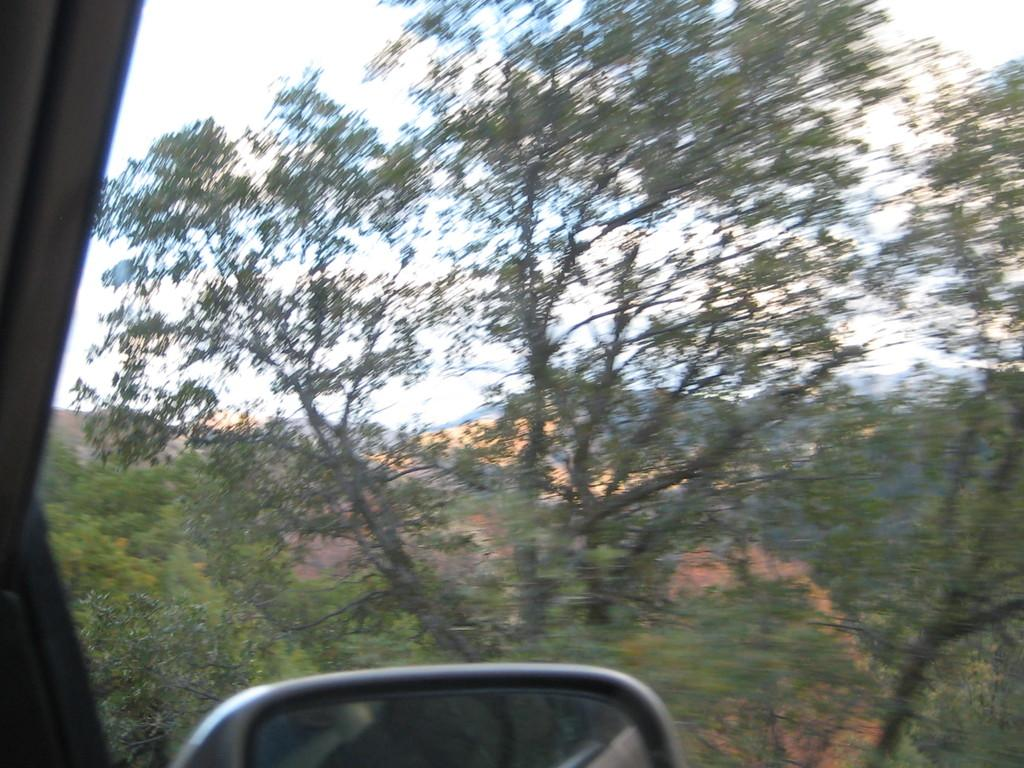What type of transparent material is present in the image? There is a glass window in the image. What is another reflective surface that can be seen in the image? There is a mirror in the image. What can be seen through the glass window? Trees and mountains are visible through the glass window. What is visible at the top of the image? The sky is visible at the top of the image. How many marks are visible on the mirror in the image? There are no marks visible on the mirror in the image. What is the fifth object in the image? The provided facts do not indicate a specific order of objects in the image, so it is not possible to determine the fifth object. 